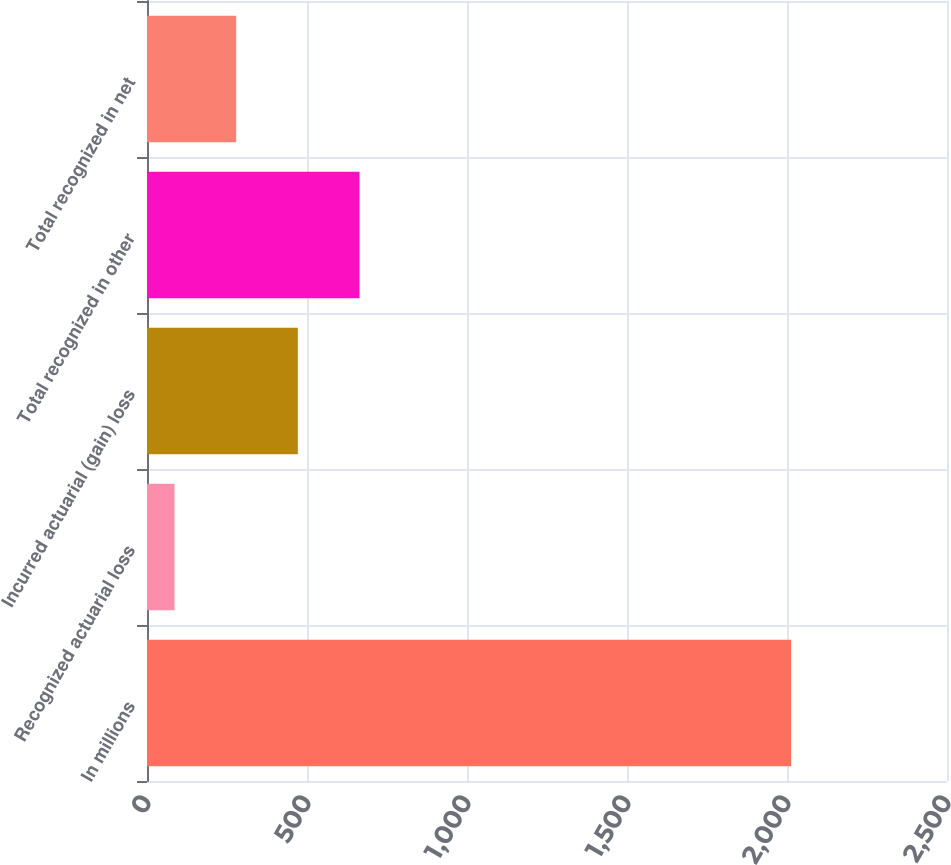<chart> <loc_0><loc_0><loc_500><loc_500><bar_chart><fcel>In millions<fcel>Recognized actuarial loss<fcel>Incurred actuarial (gain) loss<fcel>Total recognized in other<fcel>Total recognized in net<nl><fcel>2013<fcel>86<fcel>471.4<fcel>664.1<fcel>278.7<nl></chart> 